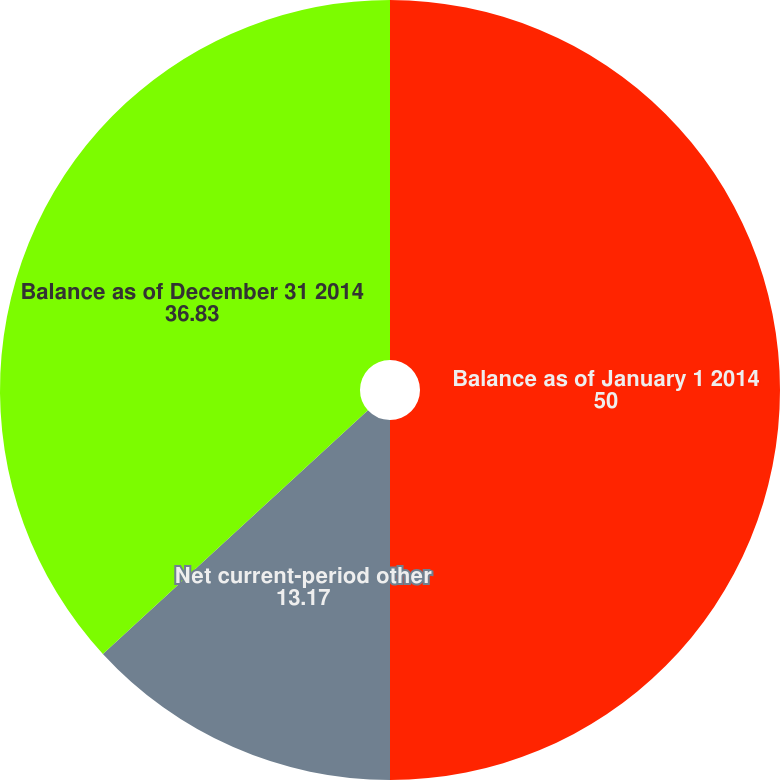Convert chart to OTSL. <chart><loc_0><loc_0><loc_500><loc_500><pie_chart><fcel>Balance as of January 1 2014<fcel>Net current-period other<fcel>Balance as of December 31 2014<nl><fcel>50.0%<fcel>13.17%<fcel>36.83%<nl></chart> 